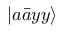Convert formula to latex. <formula><loc_0><loc_0><loc_500><loc_500>\left | a \bar { a } y y \right \rangle</formula> 